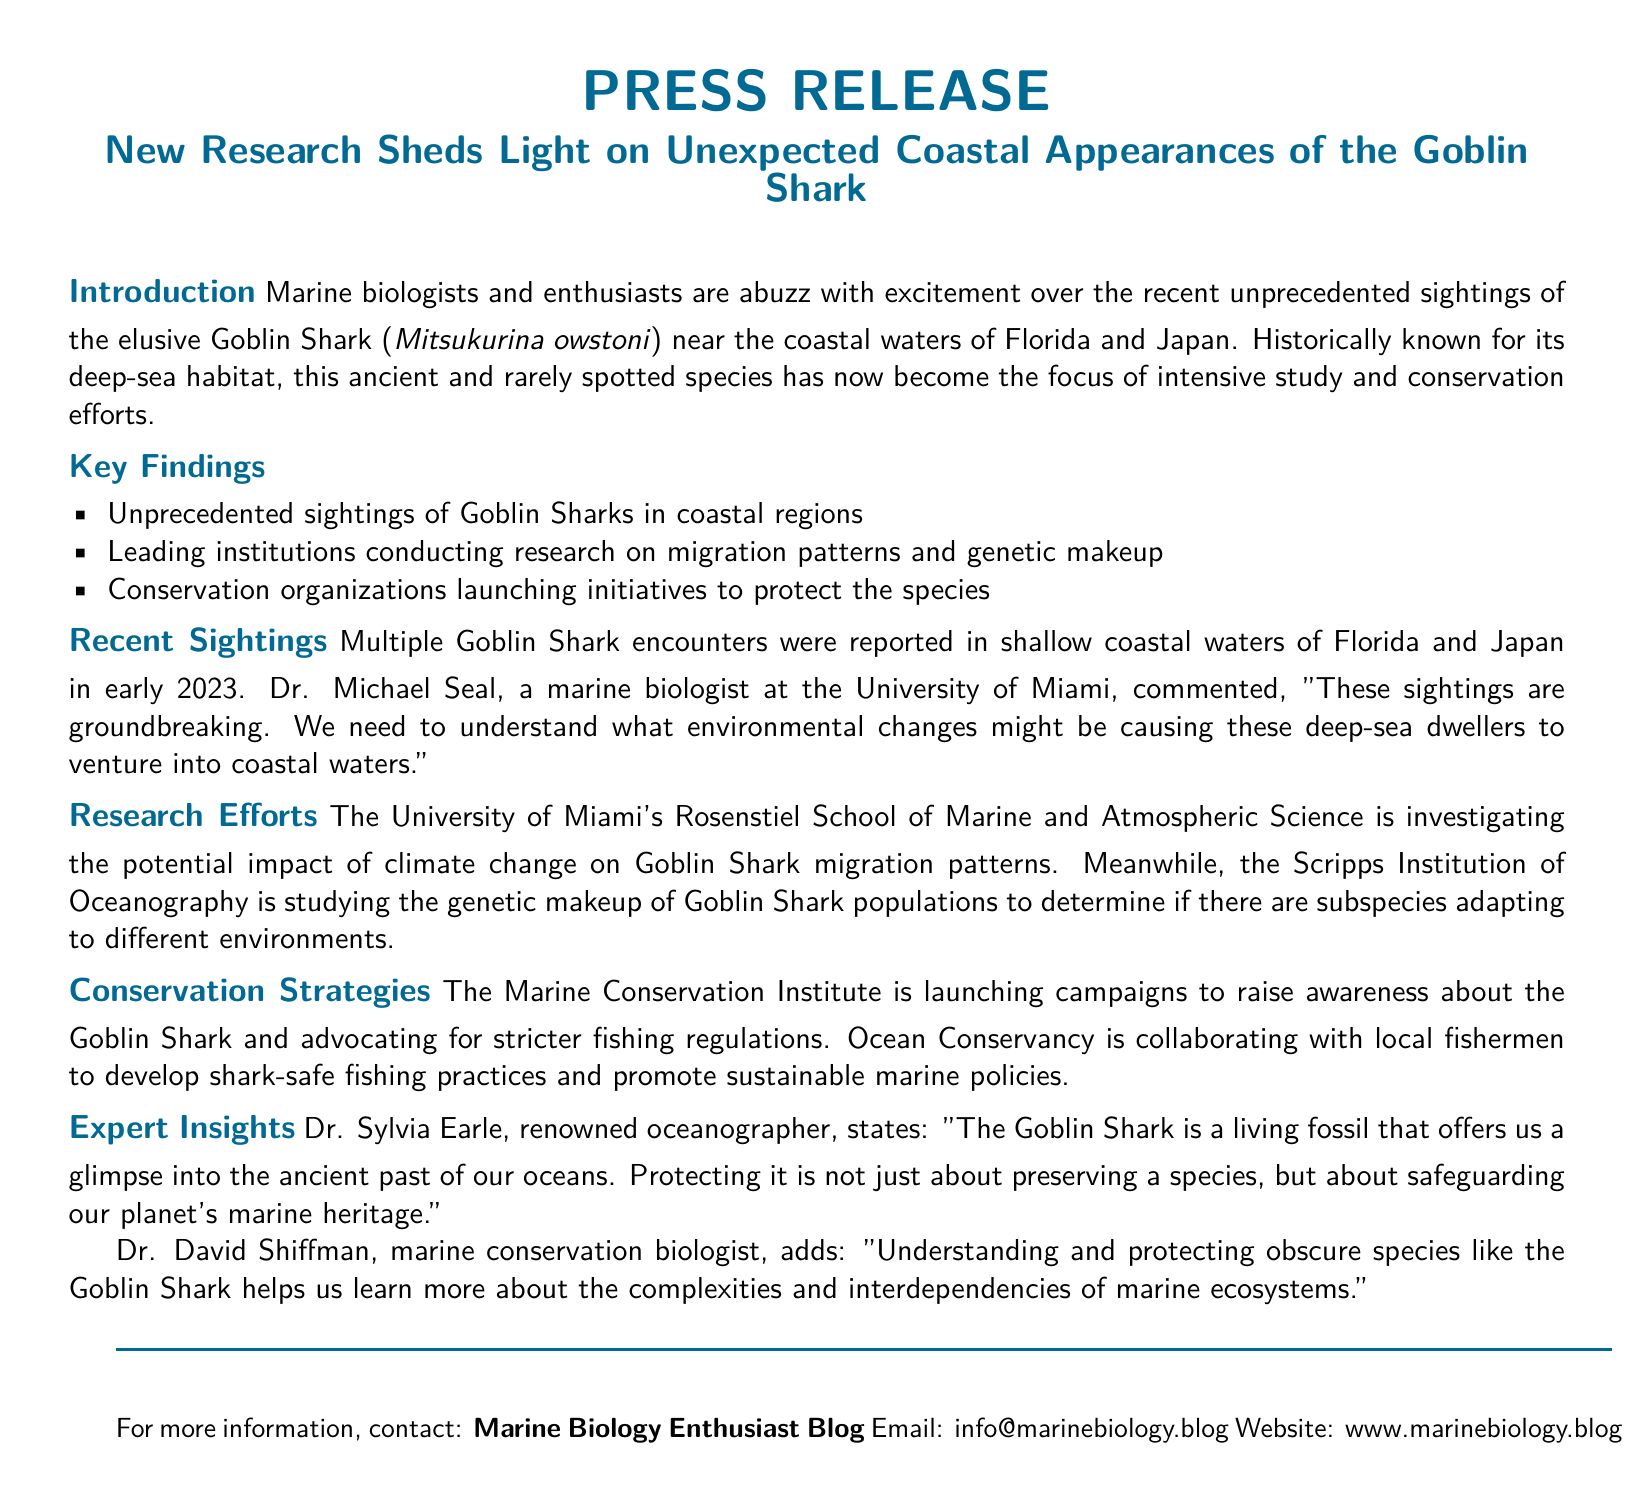What species is the focus of the press release? The press release discusses sightings and conservation efforts specifically for the Goblin Shark.
Answer: Goblin Shark Who commented on the groundbreaking sightings? Dr. Michael Seal expressed his views on the sightings in the coastal waters.
Answer: Dr. Michael Seal Which two coastal regions reported Goblin Shark sightings? The document mentions sightings occurring in Florida and Japan.
Answer: Florida and Japan What institution is investigating the impact of climate change on Goblin Shark migration? The University of Miami's Rosenstiel School is conducting this research.
Answer: University of Miami's Rosenstiel School What is the goal of the Marine Conservation Institute's campaigns? The campaigns aim to raise awareness about the Goblin Shark and advocate for stricter fishing regulations.
Answer: Raise awareness and advocate for stricter fishing regulations Who is the renowned oceanographer mentioned in the press release? Dr. Sylvia Earle is the expert cited in the document.
Answer: Dr. Sylvia Earle What might be a reason for the Goblin Sharks to venture into coastal waters? Environmental changes are suggested as a possible cause for these sightings.
Answer: Environmental changes Which organization is collaborating with local fishermen? Ocean Conservancy is the organization mentioned for collaboration efforts.
Answer: Ocean Conservancy What year were the sightings of the Goblin Shark reported? The sightings were reported in early 2023 as indicated in the document.
Answer: 2023 